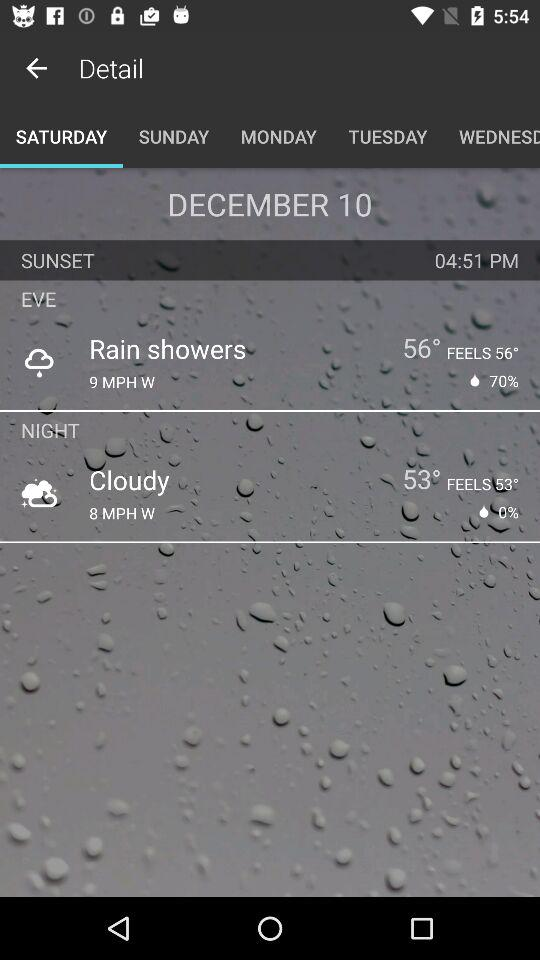What date is displayed on the screen? The date displayed on the screen is December 10. 